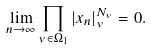Convert formula to latex. <formula><loc_0><loc_0><loc_500><loc_500>\lim _ { n \to \infty } \prod _ { v \in \Omega _ { 1 } } | x _ { n } | _ { v } ^ { N _ { v } } = 0 .</formula> 